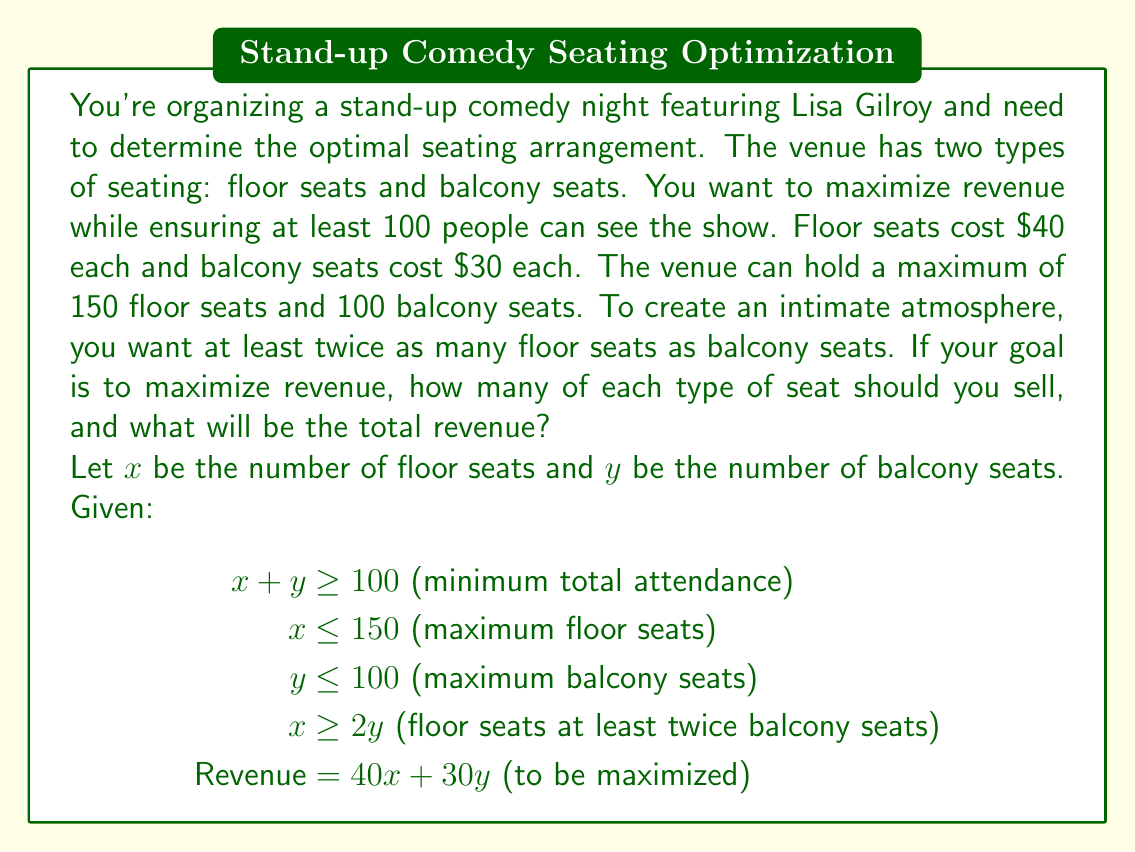Provide a solution to this math problem. To solve this problem, we'll use the simplex method for linear programming:

1) First, convert the inequalities to equations by introducing slack variables:
   $$\begin{align*}
   x + y - s_1 &= 100\\
   x + s_2 &= 150\\
   y + s_3 &= 100\\
   x - 2y - s_4 &= 0
   \end{align*}$$

2) The objective function to maximize is:
   $$z = 40x + 30y$$

3) Set up the initial simplex tableau:

   $$\begin{array}{c|cccccccc}
   \text{Basic} & x & y & s_1 & s_2 & s_3 & s_4 & \text{RHS} \\
   \hline
   s_1 & 1 & 1 & 1 & 0 & 0 & 0 & 100 \\
   s_2 & 1 & 0 & 0 & 1 & 0 & 0 & 150 \\
   s_3 & 0 & 1 & 0 & 0 & 1 & 0 & 100 \\
   s_4 & 1 & -2 & 0 & 0 & 0 & 1 & 0 \\
   \hline
   z & -40 & -30 & 0 & 0 & 0 & 0 & 0
   \end{array}$$

4) Perform pivot operations until all entries in the bottom row are non-negative.

5) After several iterations, we reach the optimal solution:

   $$\begin{array}{c|cccccccc}
   \text{Basic} & x & y & s_1 & s_2 & s_3 & s_4 & \text{RHS} \\
   \hline
   x & 1 & 0 & 0 & 1 & 0 & 0 & 150 \\
   y & 0 & 1 & 0 & 0 & 1 & 0 & 75 \\
   s_1 & 0 & 0 & 1 & -1 & -1 & 0 & -125 \\
   s_4 & 0 & 0 & 0 & 2 & -2 & 1 & 0 \\
   \hline
   z & 0 & 0 & 0 & 40 & 30 & 0 & 8250
   \end{array}$$

6) From this final tableau, we can read the optimal solution:
   $x = 150$ (floor seats)
   $y = 75$ (balcony seats)
   $z = 8250$ (total revenue)

This solution satisfies all constraints:
- Total attendance: $150 + 75 = 225 \geq 100$
- Floor seats: $150 \leq 150$
- Balcony seats: $75 \leq 100$
- Floor seats at least twice balcony seats: $150 \geq 2(75)$

Therefore, the optimal seating arrangement is 150 floor seats and 75 balcony seats.
Answer: The optimal seating arrangement is 150 floor seats and 75 balcony seats, generating a total revenue of $8,250. 